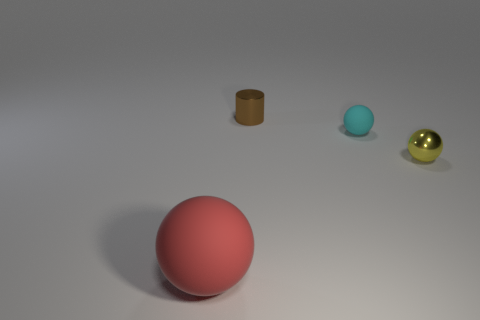There is a tiny matte object; are there any tiny yellow balls behind it?
Give a very brief answer. No. What size is the red object that is made of the same material as the cyan object?
Give a very brief answer. Large. What number of cyan objects have the same shape as the small brown object?
Your answer should be compact. 0. Are the large thing and the yellow object in front of the brown thing made of the same material?
Ensure brevity in your answer.  No. Are there more cylinders that are behind the large red object than small purple spheres?
Make the answer very short. Yes. Is there a red cylinder that has the same material as the big sphere?
Offer a terse response. No. Is the material of the small thing that is right of the tiny cyan sphere the same as the thing left of the brown object?
Your response must be concise. No. Is the number of large red matte balls right of the small rubber thing the same as the number of small yellow balls in front of the red object?
Your response must be concise. Yes. There is a matte sphere that is the same size as the brown metallic cylinder; what color is it?
Provide a succinct answer. Cyan. Is there a thing of the same color as the small matte sphere?
Make the answer very short. No. 